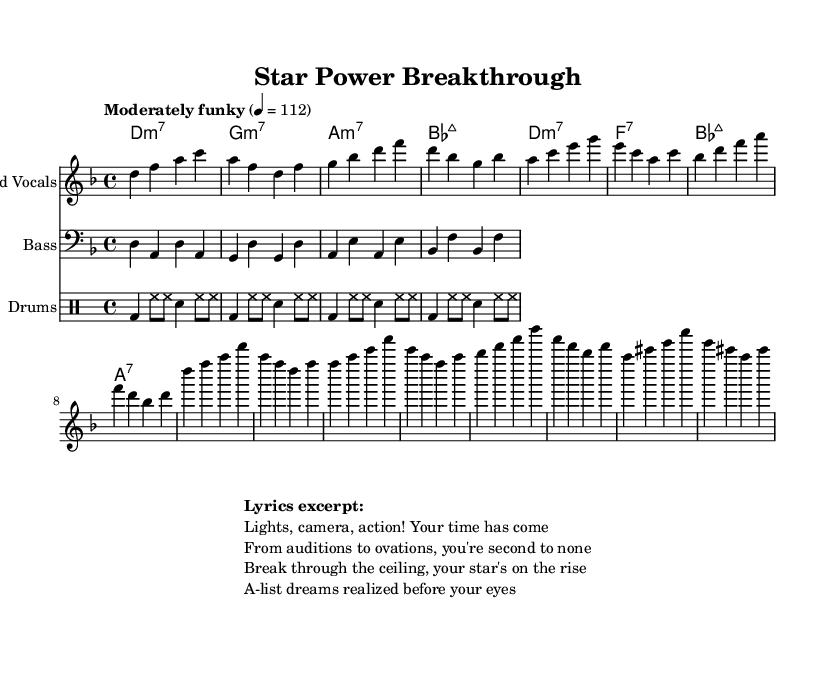What is the key signature of this music? The key signature is D minor, which has one flat (B flat). This indicates that the piece is centered around D as the tonic note, and other notes follow the D minor scale.
Answer: D minor What is the time signature of this music? The time signature is 4/4, which means there are four beats in each measure and the quarter note receives one beat. This is indicated at the beginning of the score.
Answer: 4/4 What is the tempo marking of this music? The tempo marking is "Moderately funky," which suggests a lively and rhythmic feel typical in funk music. The note value given is 4 equals 112, providing a specific speed for performance.
Answer: Moderately funky How many measures are in the verse section? The verse section consists of four measures, as indicated by the four groups of notes followed by the indication of measures in the melody. Each line in the melody represents a new measure.
Answer: Four measures Which instrument plays the bass line? The bass line is played by the instrument labeled "Bass," which is a common designation for the bass instrument in sheet music. This is indicated by the instrument name in the staff section of the score.
Answer: Bass What type of chords are used in the verse? The chords used in the verse are minor seventh chords, specifically indicated by the "m7" notation next to the chord names in the chord section of the score. This suggests a soulful and rich harmonic texture typical in soul music.
Answer: Minor seventh chords What does the lyric excerpt hint about the themes of the song? The lyric excerpt suggests themes of ambition and success in the entertainment industry, emphasizing personal breakthroughs and the realization of dreams. The words convey a sense of celebratory energy, which aligns with the overall musical style.
Answer: Ambition and success 